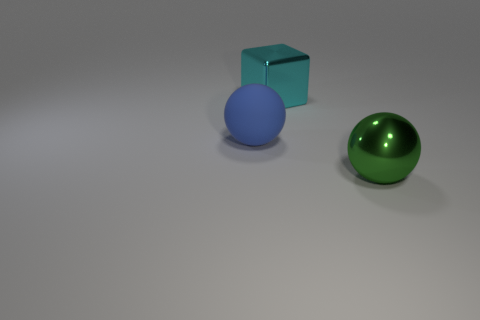What size is the object that is in front of the cyan metallic cube and right of the large blue matte ball?
Your response must be concise. Large. What number of other things are the same shape as the big matte object?
Offer a very short reply. 1. What number of other things are there of the same material as the big blue object
Your answer should be compact. 0. What size is the green thing that is the same shape as the large blue thing?
Provide a succinct answer. Large. Does the matte sphere have the same color as the block?
Your answer should be very brief. No. There is a thing that is in front of the big block and to the right of the large blue object; what is its color?
Offer a terse response. Green. What number of objects are either large balls on the right side of the blue sphere or tiny shiny cylinders?
Make the answer very short. 1. There is another object that is the same shape as the big green thing; what color is it?
Keep it short and to the point. Blue. Do the matte object and the large metal thing that is in front of the blue matte ball have the same shape?
Offer a terse response. Yes. What number of objects are big balls behind the green metal object or blue rubber things that are on the left side of the metallic block?
Provide a short and direct response. 1. 